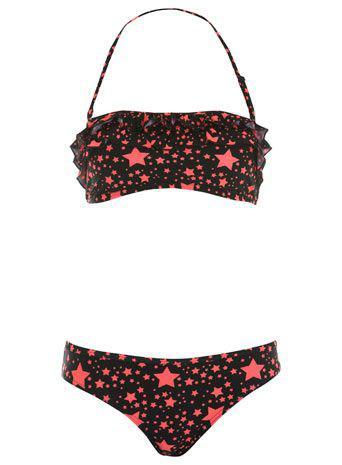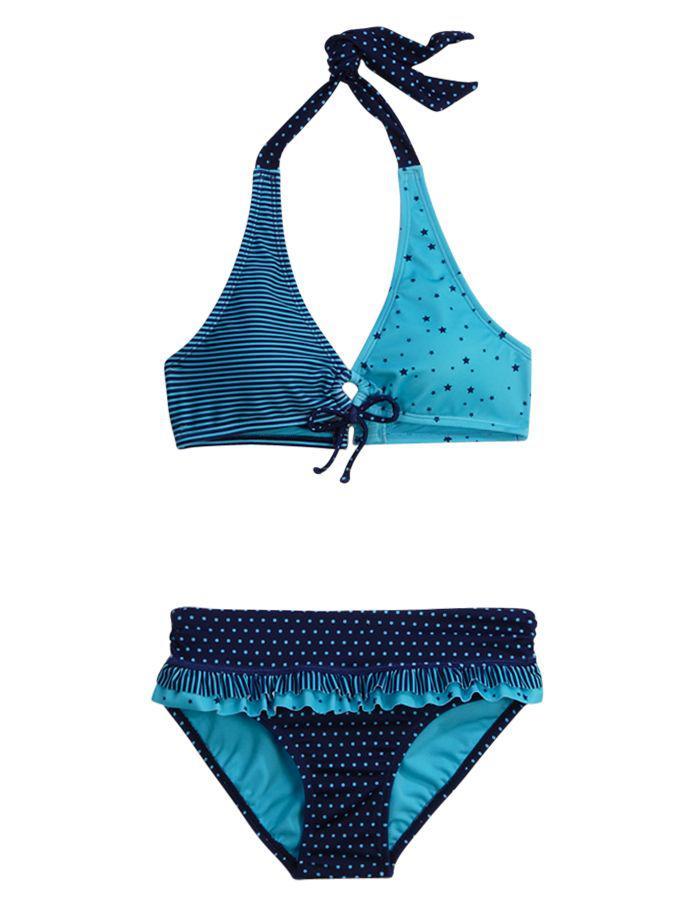The first image is the image on the left, the second image is the image on the right. For the images shown, is this caption "At least one bikini bottom ties on with strings." true? Answer yes or no. No. 